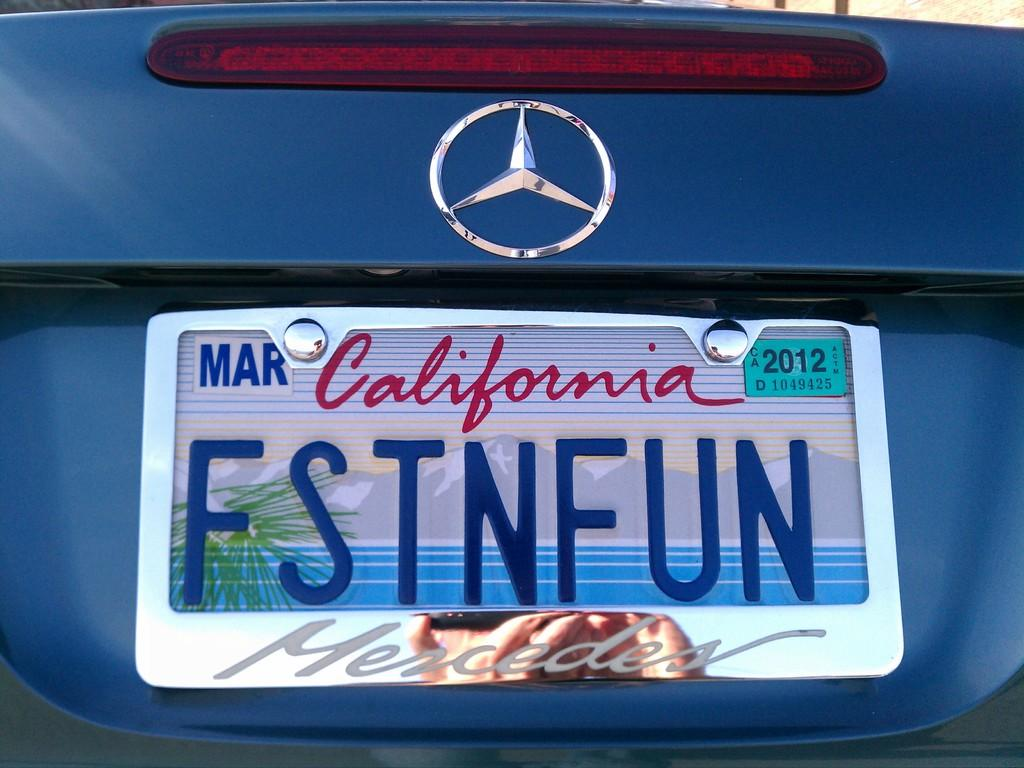<image>
Give a short and clear explanation of the subsequent image. A blue Mercedes with a California license plate says FSTNFUN. 